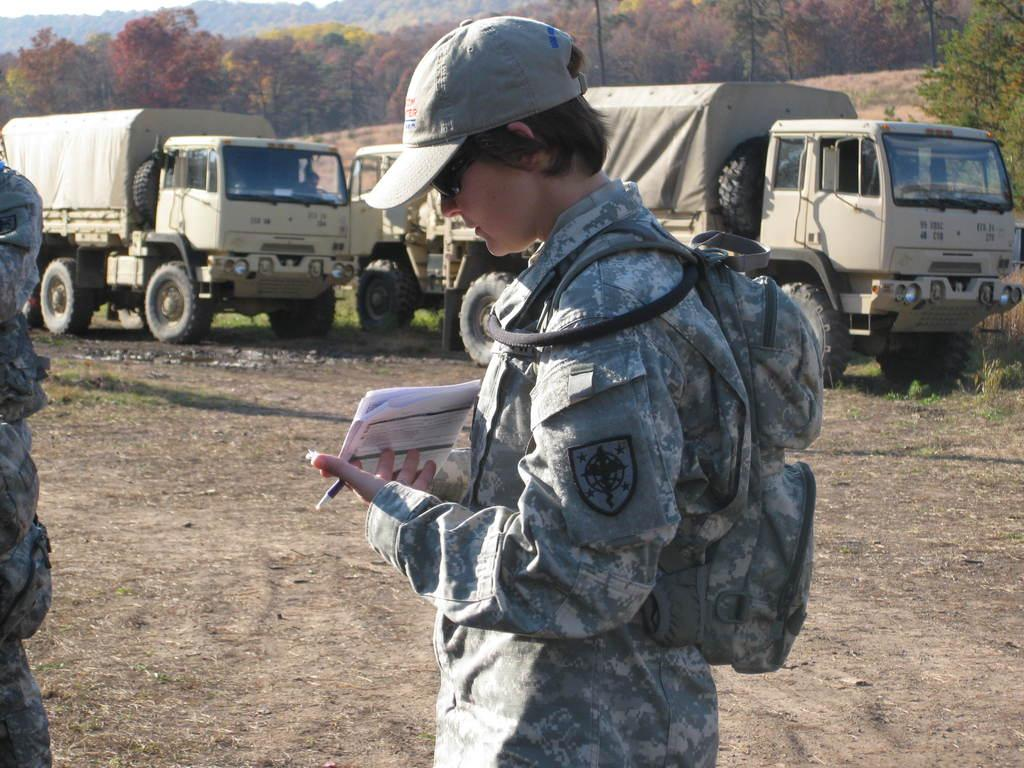How many people are in the foreground of the image? There are two persons in the foreground of the image. What are the two persons doing in the image? The two persons are on the ground. What can be seen in the background of the image? There are trucks, grass, trees, and the sky visible in the background of the image. When was the image taken? The image was taken during the day. What type of bread is being used as a pillow by one of the persons in the image? There is no bread present in the image, and the persons are not using any objects as pillows. 